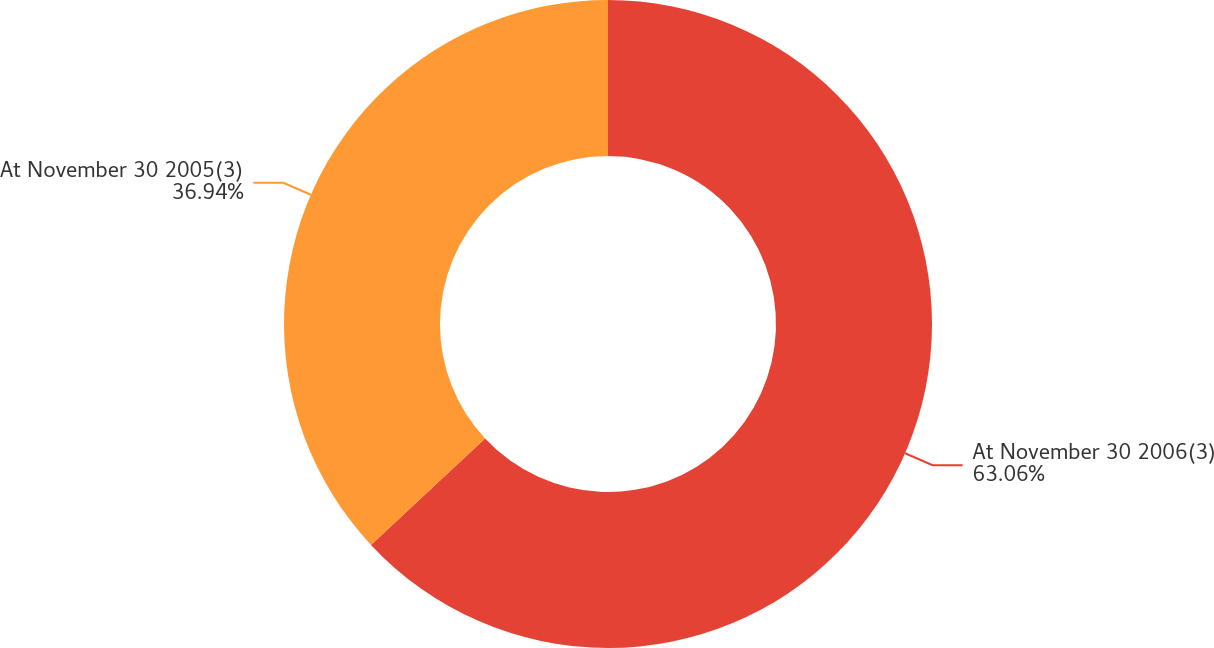Convert chart to OTSL. <chart><loc_0><loc_0><loc_500><loc_500><pie_chart><fcel>At November 30 2006(3)<fcel>At November 30 2005(3)<nl><fcel>63.06%<fcel>36.94%<nl></chart> 